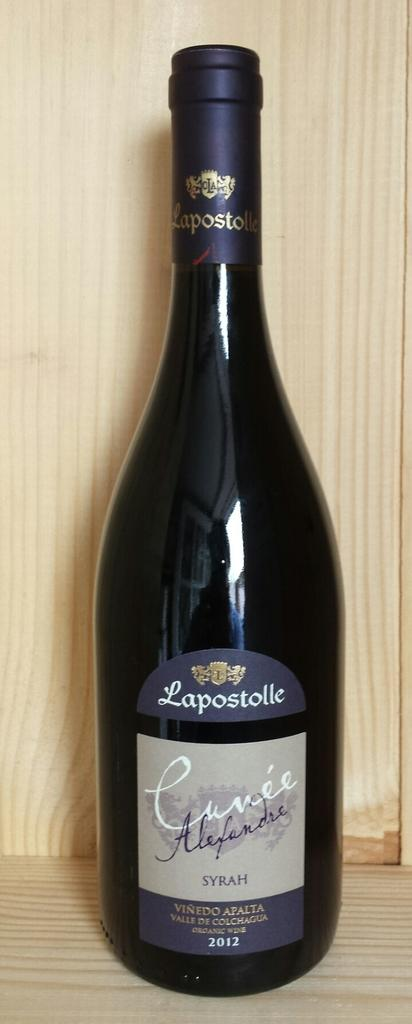<image>
Present a compact description of the photo's key features. A bottle of syrah from 2012 sits on a wooden shelf. 